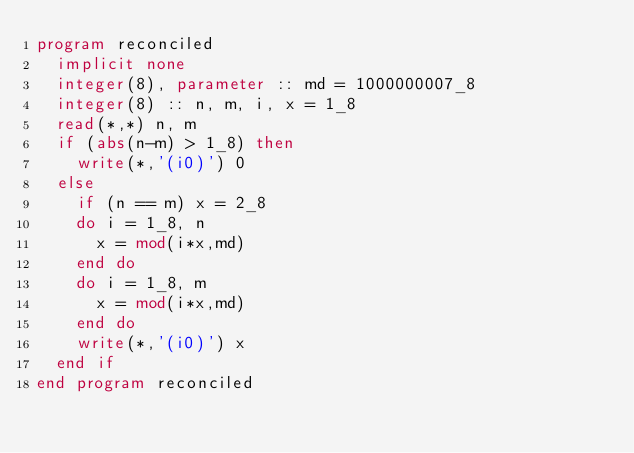<code> <loc_0><loc_0><loc_500><loc_500><_FORTRAN_>program reconciled
  implicit none
  integer(8), parameter :: md = 1000000007_8
  integer(8) :: n, m, i, x = 1_8
  read(*,*) n, m
  if (abs(n-m) > 1_8) then
    write(*,'(i0)') 0
  else
    if (n == m) x = 2_8
    do i = 1_8, n
      x = mod(i*x,md)
    end do
    do i = 1_8, m
      x = mod(i*x,md)
    end do
    write(*,'(i0)') x
  end if
end program reconciled</code> 